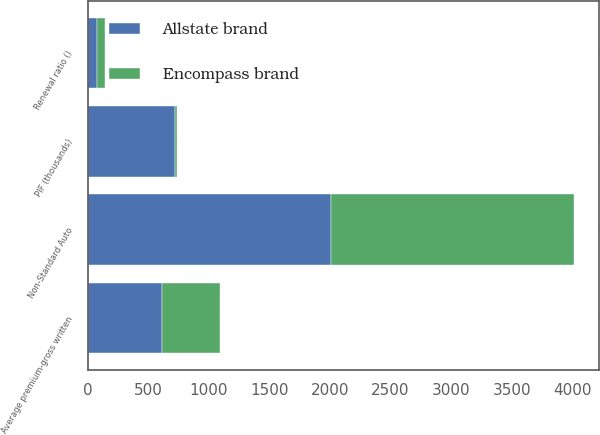Convert chart to OTSL. <chart><loc_0><loc_0><loc_500><loc_500><stacked_bar_chart><ecel><fcel>Non-Standard Auto<fcel>PIF (thousands)<fcel>Average premium-gross written<fcel>Renewal ratio ()<nl><fcel>Allstate brand<fcel>2009<fcel>719<fcel>616<fcel>72.5<nl><fcel>Encompass brand<fcel>2009<fcel>20<fcel>476<fcel>67.1<nl></chart> 